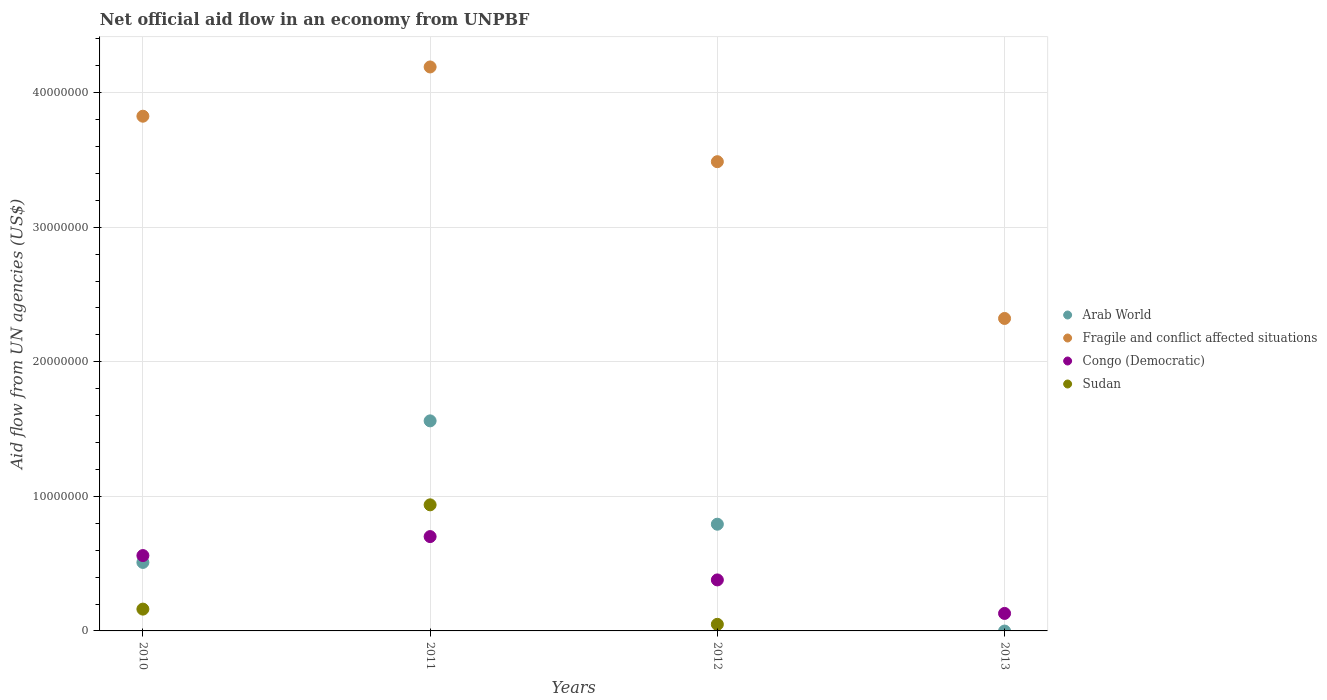How many different coloured dotlines are there?
Your answer should be compact. 4. What is the net official aid flow in Arab World in 2010?
Give a very brief answer. 5.09e+06. Across all years, what is the maximum net official aid flow in Fragile and conflict affected situations?
Offer a very short reply. 4.19e+07. Across all years, what is the minimum net official aid flow in Fragile and conflict affected situations?
Offer a terse response. 2.32e+07. What is the total net official aid flow in Fragile and conflict affected situations in the graph?
Provide a short and direct response. 1.38e+08. What is the difference between the net official aid flow in Sudan in 2010 and that in 2012?
Your answer should be very brief. 1.13e+06. What is the difference between the net official aid flow in Arab World in 2011 and the net official aid flow in Fragile and conflict affected situations in 2012?
Offer a very short reply. -1.93e+07. What is the average net official aid flow in Sudan per year?
Offer a terse response. 2.87e+06. In the year 2010, what is the difference between the net official aid flow in Arab World and net official aid flow in Fragile and conflict affected situations?
Your response must be concise. -3.32e+07. What is the ratio of the net official aid flow in Congo (Democratic) in 2011 to that in 2013?
Keep it short and to the point. 5.39. Is the difference between the net official aid flow in Arab World in 2011 and 2012 greater than the difference between the net official aid flow in Fragile and conflict affected situations in 2011 and 2012?
Your answer should be very brief. Yes. What is the difference between the highest and the second highest net official aid flow in Congo (Democratic)?
Give a very brief answer. 1.41e+06. What is the difference between the highest and the lowest net official aid flow in Arab World?
Provide a short and direct response. 1.56e+07. Is the sum of the net official aid flow in Congo (Democratic) in 2011 and 2013 greater than the maximum net official aid flow in Sudan across all years?
Provide a short and direct response. No. Is it the case that in every year, the sum of the net official aid flow in Sudan and net official aid flow in Fragile and conflict affected situations  is greater than the sum of net official aid flow in Congo (Democratic) and net official aid flow in Arab World?
Offer a terse response. No. Is the net official aid flow in Arab World strictly greater than the net official aid flow in Congo (Democratic) over the years?
Your response must be concise. No. Is the net official aid flow in Arab World strictly less than the net official aid flow in Congo (Democratic) over the years?
Your answer should be compact. No. How many dotlines are there?
Ensure brevity in your answer.  4. How many years are there in the graph?
Provide a succinct answer. 4. What is the difference between two consecutive major ticks on the Y-axis?
Provide a succinct answer. 1.00e+07. Are the values on the major ticks of Y-axis written in scientific E-notation?
Your answer should be compact. No. Where does the legend appear in the graph?
Offer a very short reply. Center right. How many legend labels are there?
Keep it short and to the point. 4. How are the legend labels stacked?
Ensure brevity in your answer.  Vertical. What is the title of the graph?
Offer a very short reply. Net official aid flow in an economy from UNPBF. What is the label or title of the X-axis?
Make the answer very short. Years. What is the label or title of the Y-axis?
Provide a short and direct response. Aid flow from UN agencies (US$). What is the Aid flow from UN agencies (US$) of Arab World in 2010?
Your response must be concise. 5.09e+06. What is the Aid flow from UN agencies (US$) in Fragile and conflict affected situations in 2010?
Offer a terse response. 3.82e+07. What is the Aid flow from UN agencies (US$) of Congo (Democratic) in 2010?
Provide a succinct answer. 5.60e+06. What is the Aid flow from UN agencies (US$) in Sudan in 2010?
Your answer should be very brief. 1.62e+06. What is the Aid flow from UN agencies (US$) in Arab World in 2011?
Your response must be concise. 1.56e+07. What is the Aid flow from UN agencies (US$) of Fragile and conflict affected situations in 2011?
Offer a very short reply. 4.19e+07. What is the Aid flow from UN agencies (US$) in Congo (Democratic) in 2011?
Offer a very short reply. 7.01e+06. What is the Aid flow from UN agencies (US$) of Sudan in 2011?
Give a very brief answer. 9.37e+06. What is the Aid flow from UN agencies (US$) of Arab World in 2012?
Offer a very short reply. 7.93e+06. What is the Aid flow from UN agencies (US$) in Fragile and conflict affected situations in 2012?
Ensure brevity in your answer.  3.49e+07. What is the Aid flow from UN agencies (US$) in Congo (Democratic) in 2012?
Keep it short and to the point. 3.79e+06. What is the Aid flow from UN agencies (US$) in Arab World in 2013?
Give a very brief answer. 0. What is the Aid flow from UN agencies (US$) of Fragile and conflict affected situations in 2013?
Provide a short and direct response. 2.32e+07. What is the Aid flow from UN agencies (US$) in Congo (Democratic) in 2013?
Provide a succinct answer. 1.30e+06. What is the Aid flow from UN agencies (US$) of Sudan in 2013?
Your answer should be very brief. 0. Across all years, what is the maximum Aid flow from UN agencies (US$) of Arab World?
Your answer should be very brief. 1.56e+07. Across all years, what is the maximum Aid flow from UN agencies (US$) in Fragile and conflict affected situations?
Offer a very short reply. 4.19e+07. Across all years, what is the maximum Aid flow from UN agencies (US$) in Congo (Democratic)?
Your answer should be very brief. 7.01e+06. Across all years, what is the maximum Aid flow from UN agencies (US$) in Sudan?
Ensure brevity in your answer.  9.37e+06. Across all years, what is the minimum Aid flow from UN agencies (US$) in Fragile and conflict affected situations?
Provide a short and direct response. 2.32e+07. Across all years, what is the minimum Aid flow from UN agencies (US$) of Congo (Democratic)?
Give a very brief answer. 1.30e+06. What is the total Aid flow from UN agencies (US$) in Arab World in the graph?
Give a very brief answer. 2.86e+07. What is the total Aid flow from UN agencies (US$) of Fragile and conflict affected situations in the graph?
Offer a terse response. 1.38e+08. What is the total Aid flow from UN agencies (US$) of Congo (Democratic) in the graph?
Your answer should be very brief. 1.77e+07. What is the total Aid flow from UN agencies (US$) in Sudan in the graph?
Ensure brevity in your answer.  1.15e+07. What is the difference between the Aid flow from UN agencies (US$) in Arab World in 2010 and that in 2011?
Offer a very short reply. -1.05e+07. What is the difference between the Aid flow from UN agencies (US$) in Fragile and conflict affected situations in 2010 and that in 2011?
Offer a terse response. -3.66e+06. What is the difference between the Aid flow from UN agencies (US$) of Congo (Democratic) in 2010 and that in 2011?
Offer a terse response. -1.41e+06. What is the difference between the Aid flow from UN agencies (US$) in Sudan in 2010 and that in 2011?
Ensure brevity in your answer.  -7.75e+06. What is the difference between the Aid flow from UN agencies (US$) of Arab World in 2010 and that in 2012?
Give a very brief answer. -2.84e+06. What is the difference between the Aid flow from UN agencies (US$) of Fragile and conflict affected situations in 2010 and that in 2012?
Give a very brief answer. 3.38e+06. What is the difference between the Aid flow from UN agencies (US$) in Congo (Democratic) in 2010 and that in 2012?
Keep it short and to the point. 1.81e+06. What is the difference between the Aid flow from UN agencies (US$) in Sudan in 2010 and that in 2012?
Your answer should be compact. 1.13e+06. What is the difference between the Aid flow from UN agencies (US$) in Fragile and conflict affected situations in 2010 and that in 2013?
Offer a terse response. 1.50e+07. What is the difference between the Aid flow from UN agencies (US$) of Congo (Democratic) in 2010 and that in 2013?
Keep it short and to the point. 4.30e+06. What is the difference between the Aid flow from UN agencies (US$) of Arab World in 2011 and that in 2012?
Ensure brevity in your answer.  7.68e+06. What is the difference between the Aid flow from UN agencies (US$) in Fragile and conflict affected situations in 2011 and that in 2012?
Your answer should be compact. 7.04e+06. What is the difference between the Aid flow from UN agencies (US$) in Congo (Democratic) in 2011 and that in 2012?
Provide a succinct answer. 3.22e+06. What is the difference between the Aid flow from UN agencies (US$) of Sudan in 2011 and that in 2012?
Ensure brevity in your answer.  8.88e+06. What is the difference between the Aid flow from UN agencies (US$) in Fragile and conflict affected situations in 2011 and that in 2013?
Provide a short and direct response. 1.87e+07. What is the difference between the Aid flow from UN agencies (US$) of Congo (Democratic) in 2011 and that in 2013?
Offer a terse response. 5.71e+06. What is the difference between the Aid flow from UN agencies (US$) of Fragile and conflict affected situations in 2012 and that in 2013?
Give a very brief answer. 1.16e+07. What is the difference between the Aid flow from UN agencies (US$) of Congo (Democratic) in 2012 and that in 2013?
Keep it short and to the point. 2.49e+06. What is the difference between the Aid flow from UN agencies (US$) of Arab World in 2010 and the Aid flow from UN agencies (US$) of Fragile and conflict affected situations in 2011?
Provide a short and direct response. -3.68e+07. What is the difference between the Aid flow from UN agencies (US$) in Arab World in 2010 and the Aid flow from UN agencies (US$) in Congo (Democratic) in 2011?
Provide a succinct answer. -1.92e+06. What is the difference between the Aid flow from UN agencies (US$) in Arab World in 2010 and the Aid flow from UN agencies (US$) in Sudan in 2011?
Your answer should be very brief. -4.28e+06. What is the difference between the Aid flow from UN agencies (US$) of Fragile and conflict affected situations in 2010 and the Aid flow from UN agencies (US$) of Congo (Democratic) in 2011?
Keep it short and to the point. 3.12e+07. What is the difference between the Aid flow from UN agencies (US$) of Fragile and conflict affected situations in 2010 and the Aid flow from UN agencies (US$) of Sudan in 2011?
Your answer should be very brief. 2.89e+07. What is the difference between the Aid flow from UN agencies (US$) in Congo (Democratic) in 2010 and the Aid flow from UN agencies (US$) in Sudan in 2011?
Ensure brevity in your answer.  -3.77e+06. What is the difference between the Aid flow from UN agencies (US$) of Arab World in 2010 and the Aid flow from UN agencies (US$) of Fragile and conflict affected situations in 2012?
Make the answer very short. -2.98e+07. What is the difference between the Aid flow from UN agencies (US$) in Arab World in 2010 and the Aid flow from UN agencies (US$) in Congo (Democratic) in 2012?
Your answer should be very brief. 1.30e+06. What is the difference between the Aid flow from UN agencies (US$) in Arab World in 2010 and the Aid flow from UN agencies (US$) in Sudan in 2012?
Your response must be concise. 4.60e+06. What is the difference between the Aid flow from UN agencies (US$) of Fragile and conflict affected situations in 2010 and the Aid flow from UN agencies (US$) of Congo (Democratic) in 2012?
Give a very brief answer. 3.45e+07. What is the difference between the Aid flow from UN agencies (US$) of Fragile and conflict affected situations in 2010 and the Aid flow from UN agencies (US$) of Sudan in 2012?
Offer a very short reply. 3.78e+07. What is the difference between the Aid flow from UN agencies (US$) in Congo (Democratic) in 2010 and the Aid flow from UN agencies (US$) in Sudan in 2012?
Offer a terse response. 5.11e+06. What is the difference between the Aid flow from UN agencies (US$) in Arab World in 2010 and the Aid flow from UN agencies (US$) in Fragile and conflict affected situations in 2013?
Give a very brief answer. -1.81e+07. What is the difference between the Aid flow from UN agencies (US$) in Arab World in 2010 and the Aid flow from UN agencies (US$) in Congo (Democratic) in 2013?
Ensure brevity in your answer.  3.79e+06. What is the difference between the Aid flow from UN agencies (US$) of Fragile and conflict affected situations in 2010 and the Aid flow from UN agencies (US$) of Congo (Democratic) in 2013?
Offer a very short reply. 3.70e+07. What is the difference between the Aid flow from UN agencies (US$) in Arab World in 2011 and the Aid flow from UN agencies (US$) in Fragile and conflict affected situations in 2012?
Ensure brevity in your answer.  -1.93e+07. What is the difference between the Aid flow from UN agencies (US$) of Arab World in 2011 and the Aid flow from UN agencies (US$) of Congo (Democratic) in 2012?
Ensure brevity in your answer.  1.18e+07. What is the difference between the Aid flow from UN agencies (US$) in Arab World in 2011 and the Aid flow from UN agencies (US$) in Sudan in 2012?
Give a very brief answer. 1.51e+07. What is the difference between the Aid flow from UN agencies (US$) of Fragile and conflict affected situations in 2011 and the Aid flow from UN agencies (US$) of Congo (Democratic) in 2012?
Offer a terse response. 3.81e+07. What is the difference between the Aid flow from UN agencies (US$) of Fragile and conflict affected situations in 2011 and the Aid flow from UN agencies (US$) of Sudan in 2012?
Give a very brief answer. 4.14e+07. What is the difference between the Aid flow from UN agencies (US$) in Congo (Democratic) in 2011 and the Aid flow from UN agencies (US$) in Sudan in 2012?
Offer a terse response. 6.52e+06. What is the difference between the Aid flow from UN agencies (US$) of Arab World in 2011 and the Aid flow from UN agencies (US$) of Fragile and conflict affected situations in 2013?
Ensure brevity in your answer.  -7.61e+06. What is the difference between the Aid flow from UN agencies (US$) in Arab World in 2011 and the Aid flow from UN agencies (US$) in Congo (Democratic) in 2013?
Make the answer very short. 1.43e+07. What is the difference between the Aid flow from UN agencies (US$) of Fragile and conflict affected situations in 2011 and the Aid flow from UN agencies (US$) of Congo (Democratic) in 2013?
Your response must be concise. 4.06e+07. What is the difference between the Aid flow from UN agencies (US$) of Arab World in 2012 and the Aid flow from UN agencies (US$) of Fragile and conflict affected situations in 2013?
Make the answer very short. -1.53e+07. What is the difference between the Aid flow from UN agencies (US$) in Arab World in 2012 and the Aid flow from UN agencies (US$) in Congo (Democratic) in 2013?
Keep it short and to the point. 6.63e+06. What is the difference between the Aid flow from UN agencies (US$) in Fragile and conflict affected situations in 2012 and the Aid flow from UN agencies (US$) in Congo (Democratic) in 2013?
Your answer should be very brief. 3.36e+07. What is the average Aid flow from UN agencies (US$) of Arab World per year?
Give a very brief answer. 7.16e+06. What is the average Aid flow from UN agencies (US$) in Fragile and conflict affected situations per year?
Your answer should be very brief. 3.46e+07. What is the average Aid flow from UN agencies (US$) in Congo (Democratic) per year?
Your response must be concise. 4.42e+06. What is the average Aid flow from UN agencies (US$) in Sudan per year?
Provide a short and direct response. 2.87e+06. In the year 2010, what is the difference between the Aid flow from UN agencies (US$) of Arab World and Aid flow from UN agencies (US$) of Fragile and conflict affected situations?
Ensure brevity in your answer.  -3.32e+07. In the year 2010, what is the difference between the Aid flow from UN agencies (US$) in Arab World and Aid flow from UN agencies (US$) in Congo (Democratic)?
Provide a succinct answer. -5.10e+05. In the year 2010, what is the difference between the Aid flow from UN agencies (US$) in Arab World and Aid flow from UN agencies (US$) in Sudan?
Offer a terse response. 3.47e+06. In the year 2010, what is the difference between the Aid flow from UN agencies (US$) of Fragile and conflict affected situations and Aid flow from UN agencies (US$) of Congo (Democratic)?
Your answer should be very brief. 3.26e+07. In the year 2010, what is the difference between the Aid flow from UN agencies (US$) in Fragile and conflict affected situations and Aid flow from UN agencies (US$) in Sudan?
Your response must be concise. 3.66e+07. In the year 2010, what is the difference between the Aid flow from UN agencies (US$) of Congo (Democratic) and Aid flow from UN agencies (US$) of Sudan?
Provide a succinct answer. 3.98e+06. In the year 2011, what is the difference between the Aid flow from UN agencies (US$) in Arab World and Aid flow from UN agencies (US$) in Fragile and conflict affected situations?
Provide a succinct answer. -2.63e+07. In the year 2011, what is the difference between the Aid flow from UN agencies (US$) of Arab World and Aid flow from UN agencies (US$) of Congo (Democratic)?
Provide a short and direct response. 8.60e+06. In the year 2011, what is the difference between the Aid flow from UN agencies (US$) of Arab World and Aid flow from UN agencies (US$) of Sudan?
Offer a terse response. 6.24e+06. In the year 2011, what is the difference between the Aid flow from UN agencies (US$) in Fragile and conflict affected situations and Aid flow from UN agencies (US$) in Congo (Democratic)?
Offer a very short reply. 3.49e+07. In the year 2011, what is the difference between the Aid flow from UN agencies (US$) in Fragile and conflict affected situations and Aid flow from UN agencies (US$) in Sudan?
Your answer should be compact. 3.25e+07. In the year 2011, what is the difference between the Aid flow from UN agencies (US$) of Congo (Democratic) and Aid flow from UN agencies (US$) of Sudan?
Your answer should be compact. -2.36e+06. In the year 2012, what is the difference between the Aid flow from UN agencies (US$) of Arab World and Aid flow from UN agencies (US$) of Fragile and conflict affected situations?
Ensure brevity in your answer.  -2.69e+07. In the year 2012, what is the difference between the Aid flow from UN agencies (US$) of Arab World and Aid flow from UN agencies (US$) of Congo (Democratic)?
Give a very brief answer. 4.14e+06. In the year 2012, what is the difference between the Aid flow from UN agencies (US$) in Arab World and Aid flow from UN agencies (US$) in Sudan?
Your answer should be compact. 7.44e+06. In the year 2012, what is the difference between the Aid flow from UN agencies (US$) in Fragile and conflict affected situations and Aid flow from UN agencies (US$) in Congo (Democratic)?
Provide a short and direct response. 3.11e+07. In the year 2012, what is the difference between the Aid flow from UN agencies (US$) of Fragile and conflict affected situations and Aid flow from UN agencies (US$) of Sudan?
Ensure brevity in your answer.  3.44e+07. In the year 2012, what is the difference between the Aid flow from UN agencies (US$) in Congo (Democratic) and Aid flow from UN agencies (US$) in Sudan?
Ensure brevity in your answer.  3.30e+06. In the year 2013, what is the difference between the Aid flow from UN agencies (US$) of Fragile and conflict affected situations and Aid flow from UN agencies (US$) of Congo (Democratic)?
Offer a very short reply. 2.19e+07. What is the ratio of the Aid flow from UN agencies (US$) of Arab World in 2010 to that in 2011?
Ensure brevity in your answer.  0.33. What is the ratio of the Aid flow from UN agencies (US$) in Fragile and conflict affected situations in 2010 to that in 2011?
Your answer should be very brief. 0.91. What is the ratio of the Aid flow from UN agencies (US$) of Congo (Democratic) in 2010 to that in 2011?
Your answer should be compact. 0.8. What is the ratio of the Aid flow from UN agencies (US$) of Sudan in 2010 to that in 2011?
Ensure brevity in your answer.  0.17. What is the ratio of the Aid flow from UN agencies (US$) in Arab World in 2010 to that in 2012?
Give a very brief answer. 0.64. What is the ratio of the Aid flow from UN agencies (US$) in Fragile and conflict affected situations in 2010 to that in 2012?
Provide a succinct answer. 1.1. What is the ratio of the Aid flow from UN agencies (US$) in Congo (Democratic) in 2010 to that in 2012?
Provide a succinct answer. 1.48. What is the ratio of the Aid flow from UN agencies (US$) of Sudan in 2010 to that in 2012?
Provide a succinct answer. 3.31. What is the ratio of the Aid flow from UN agencies (US$) of Fragile and conflict affected situations in 2010 to that in 2013?
Offer a terse response. 1.65. What is the ratio of the Aid flow from UN agencies (US$) in Congo (Democratic) in 2010 to that in 2013?
Provide a short and direct response. 4.31. What is the ratio of the Aid flow from UN agencies (US$) of Arab World in 2011 to that in 2012?
Your answer should be very brief. 1.97. What is the ratio of the Aid flow from UN agencies (US$) of Fragile and conflict affected situations in 2011 to that in 2012?
Keep it short and to the point. 1.2. What is the ratio of the Aid flow from UN agencies (US$) of Congo (Democratic) in 2011 to that in 2012?
Your answer should be very brief. 1.85. What is the ratio of the Aid flow from UN agencies (US$) of Sudan in 2011 to that in 2012?
Ensure brevity in your answer.  19.12. What is the ratio of the Aid flow from UN agencies (US$) in Fragile and conflict affected situations in 2011 to that in 2013?
Ensure brevity in your answer.  1.8. What is the ratio of the Aid flow from UN agencies (US$) of Congo (Democratic) in 2011 to that in 2013?
Offer a terse response. 5.39. What is the ratio of the Aid flow from UN agencies (US$) of Fragile and conflict affected situations in 2012 to that in 2013?
Make the answer very short. 1.5. What is the ratio of the Aid flow from UN agencies (US$) in Congo (Democratic) in 2012 to that in 2013?
Give a very brief answer. 2.92. What is the difference between the highest and the second highest Aid flow from UN agencies (US$) in Arab World?
Provide a succinct answer. 7.68e+06. What is the difference between the highest and the second highest Aid flow from UN agencies (US$) in Fragile and conflict affected situations?
Give a very brief answer. 3.66e+06. What is the difference between the highest and the second highest Aid flow from UN agencies (US$) in Congo (Democratic)?
Provide a succinct answer. 1.41e+06. What is the difference between the highest and the second highest Aid flow from UN agencies (US$) of Sudan?
Offer a terse response. 7.75e+06. What is the difference between the highest and the lowest Aid flow from UN agencies (US$) in Arab World?
Offer a terse response. 1.56e+07. What is the difference between the highest and the lowest Aid flow from UN agencies (US$) of Fragile and conflict affected situations?
Provide a succinct answer. 1.87e+07. What is the difference between the highest and the lowest Aid flow from UN agencies (US$) of Congo (Democratic)?
Provide a short and direct response. 5.71e+06. What is the difference between the highest and the lowest Aid flow from UN agencies (US$) of Sudan?
Ensure brevity in your answer.  9.37e+06. 